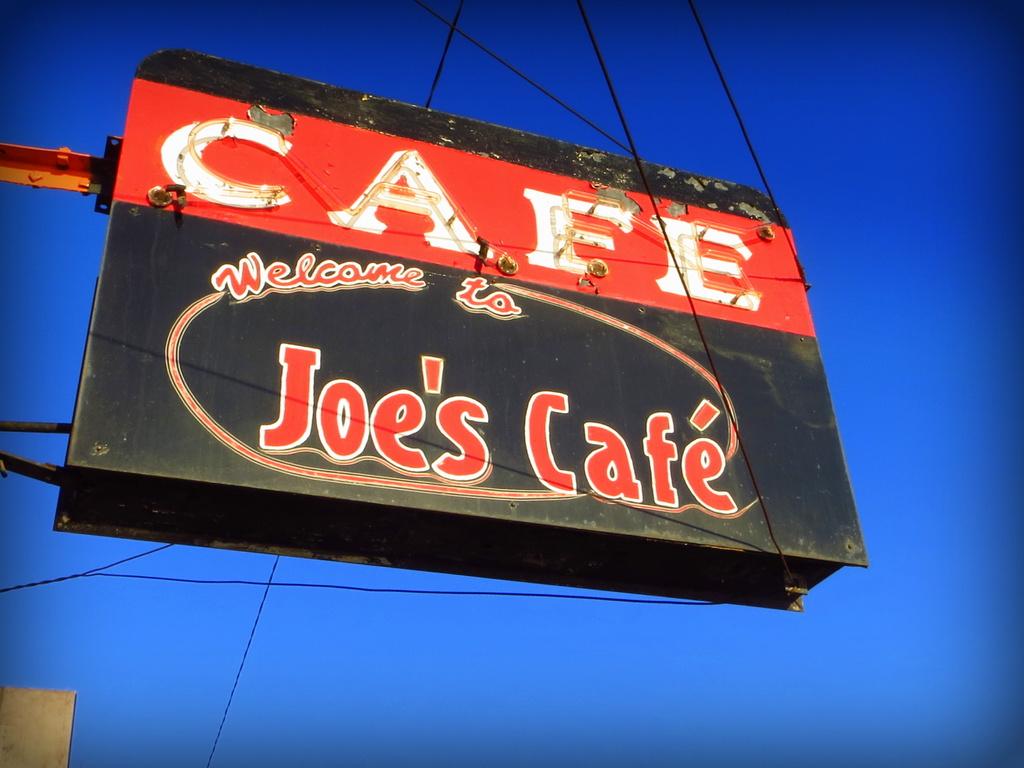What cafe are we being welcomed to?
Offer a very short reply. Joe's cafe. 